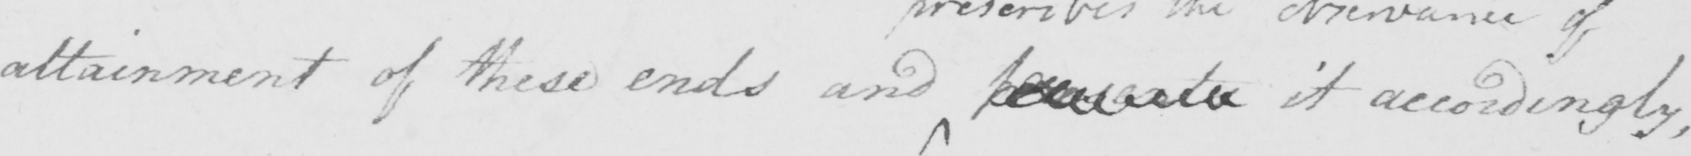What is written in this line of handwriting? attainment of these ends and <gap/> it accordingly, 